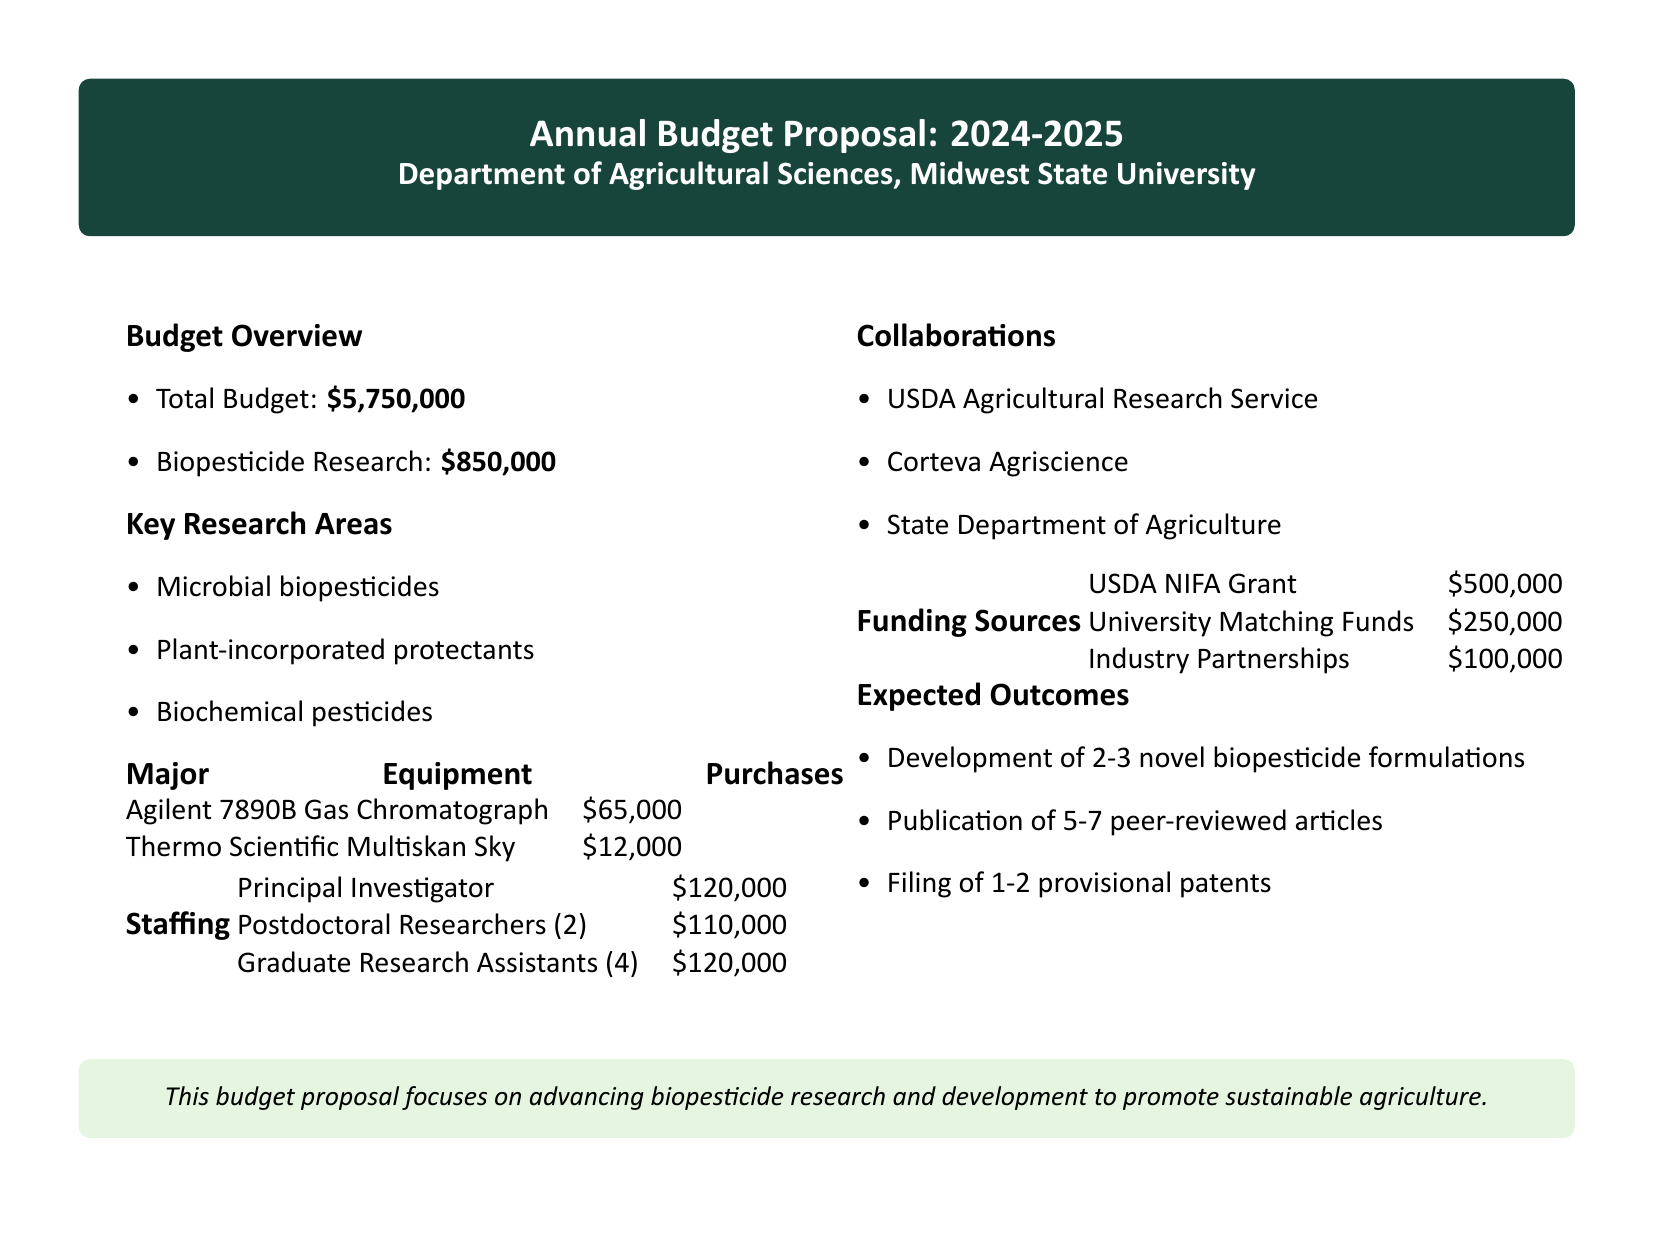What is the total budget? The total budget is stated in the overview section of the document.
Answer: $5,750,000 How much is allocated for biopesticide research? The amount allocated for biopesticide research is provided in the budget overview.
Answer: $850,000 What type of biopesticides are included in the research areas? The document lists specific types of biopesticides that are the focus of research.
Answer: Microbial biopesticides Who is the principal investigator? The staffing section mentions the principal investigator's salary but does not provide a name.
Answer: Not provided How many graduate research assistants are funded? The staffing section indicates the number of graduate research assistants funded.
Answer: 4 What is the total funding from USDA NIFA Grant? The funding sources section specifies amounts allocated from various sources, including USDA NIFA Grant.
Answer: $500,000 What is one of the expected outcomes? The expected outcomes section lists several goals for the upcoming year.
Answer: Development of 2-3 novel biopesticide formulations Which company is mentioned as a collaboration? The collaborations section lists organizations that the department is working with.
Answer: Corteva Agriscience How much is spent on the Agilent 7890B Gas Chromatograph? The major equipment purchases section details costs for specific equipment.
Answer: $65,000 